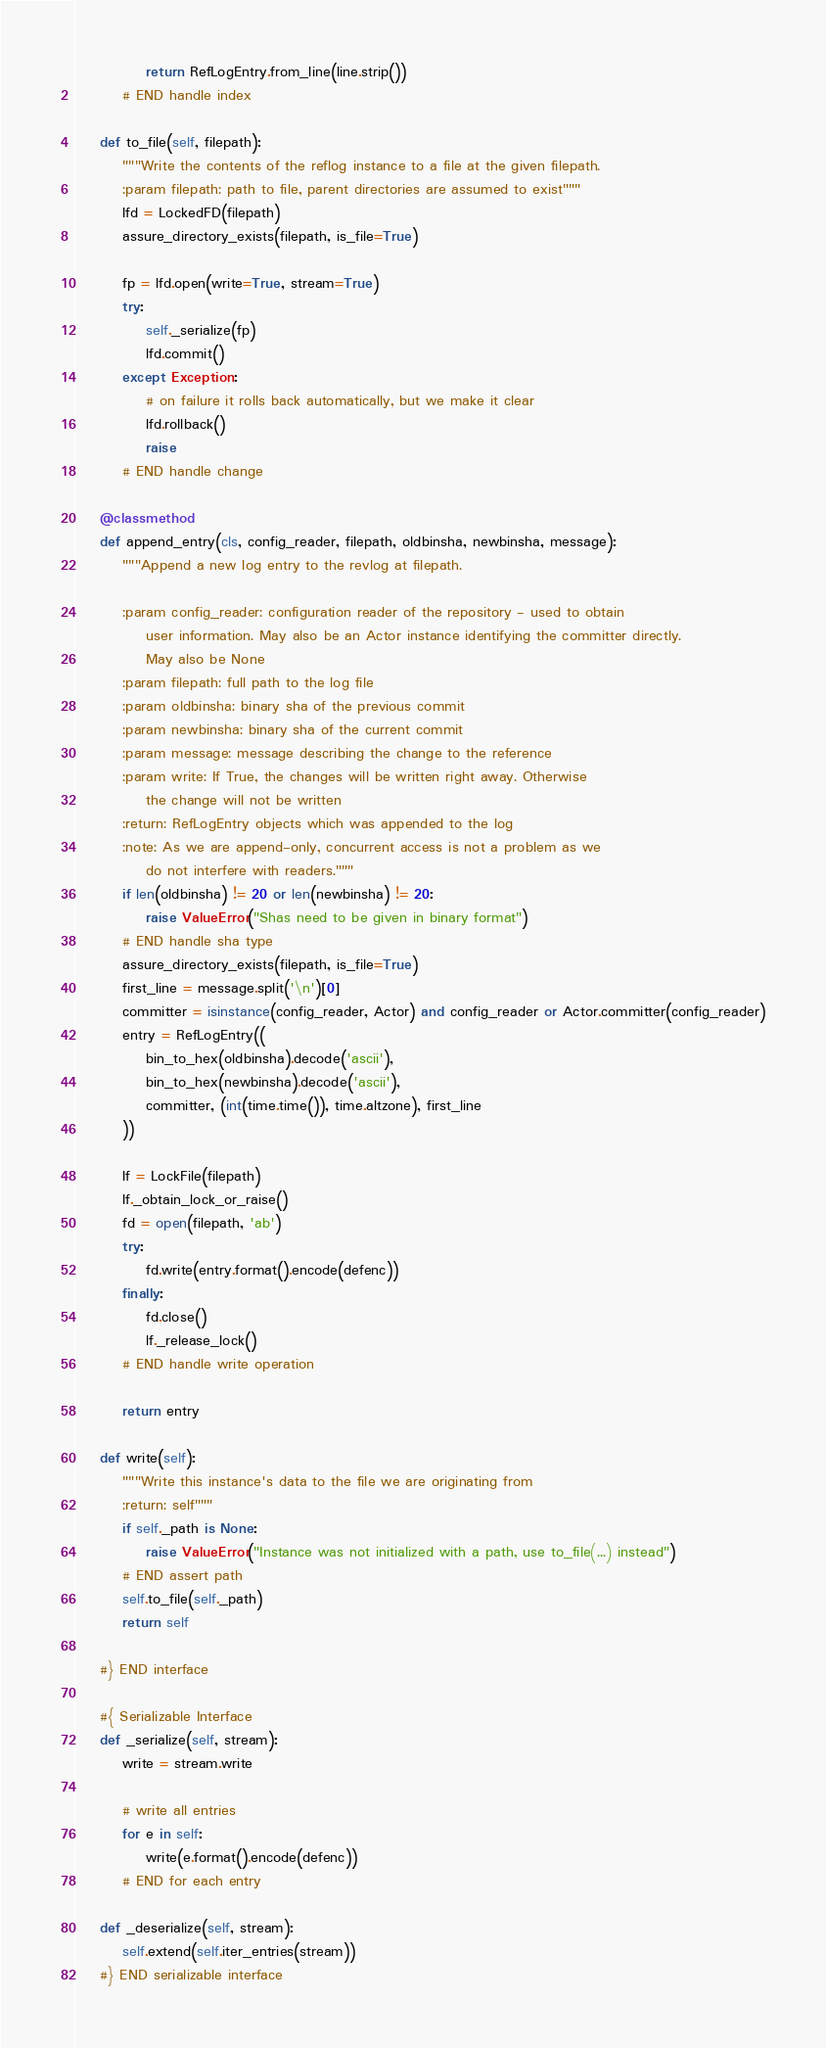Convert code to text. <code><loc_0><loc_0><loc_500><loc_500><_Python_>
            return RefLogEntry.from_line(line.strip())
        # END handle index

    def to_file(self, filepath):
        """Write the contents of the reflog instance to a file at the given filepath.
        :param filepath: path to file, parent directories are assumed to exist"""
        lfd = LockedFD(filepath)
        assure_directory_exists(filepath, is_file=True)

        fp = lfd.open(write=True, stream=True)
        try:
            self._serialize(fp)
            lfd.commit()
        except Exception:
            # on failure it rolls back automatically, but we make it clear
            lfd.rollback()
            raise
        # END handle change

    @classmethod
    def append_entry(cls, config_reader, filepath, oldbinsha, newbinsha, message):
        """Append a new log entry to the revlog at filepath.

        :param config_reader: configuration reader of the repository - used to obtain
            user information. May also be an Actor instance identifying the committer directly.
            May also be None
        :param filepath: full path to the log file
        :param oldbinsha: binary sha of the previous commit
        :param newbinsha: binary sha of the current commit
        :param message: message describing the change to the reference
        :param write: If True, the changes will be written right away. Otherwise
            the change will not be written
        :return: RefLogEntry objects which was appended to the log
        :note: As we are append-only, concurrent access is not a problem as we
            do not interfere with readers."""
        if len(oldbinsha) != 20 or len(newbinsha) != 20:
            raise ValueError("Shas need to be given in binary format")
        # END handle sha type
        assure_directory_exists(filepath, is_file=True)
        first_line = message.split('\n')[0]
        committer = isinstance(config_reader, Actor) and config_reader or Actor.committer(config_reader)
        entry = RefLogEntry((
            bin_to_hex(oldbinsha).decode('ascii'),
            bin_to_hex(newbinsha).decode('ascii'),
            committer, (int(time.time()), time.altzone), first_line
        ))

        lf = LockFile(filepath)
        lf._obtain_lock_or_raise()
        fd = open(filepath, 'ab')
        try:
            fd.write(entry.format().encode(defenc))
        finally:
            fd.close()
            lf._release_lock()
        # END handle write operation

        return entry

    def write(self):
        """Write this instance's data to the file we are originating from
        :return: self"""
        if self._path is None:
            raise ValueError("Instance was not initialized with a path, use to_file(...) instead")
        # END assert path
        self.to_file(self._path)
        return self

    #} END interface

    #{ Serializable Interface
    def _serialize(self, stream):
        write = stream.write

        # write all entries
        for e in self:
            write(e.format().encode(defenc))
        # END for each entry

    def _deserialize(self, stream):
        self.extend(self.iter_entries(stream))
    #} END serializable interface
</code> 